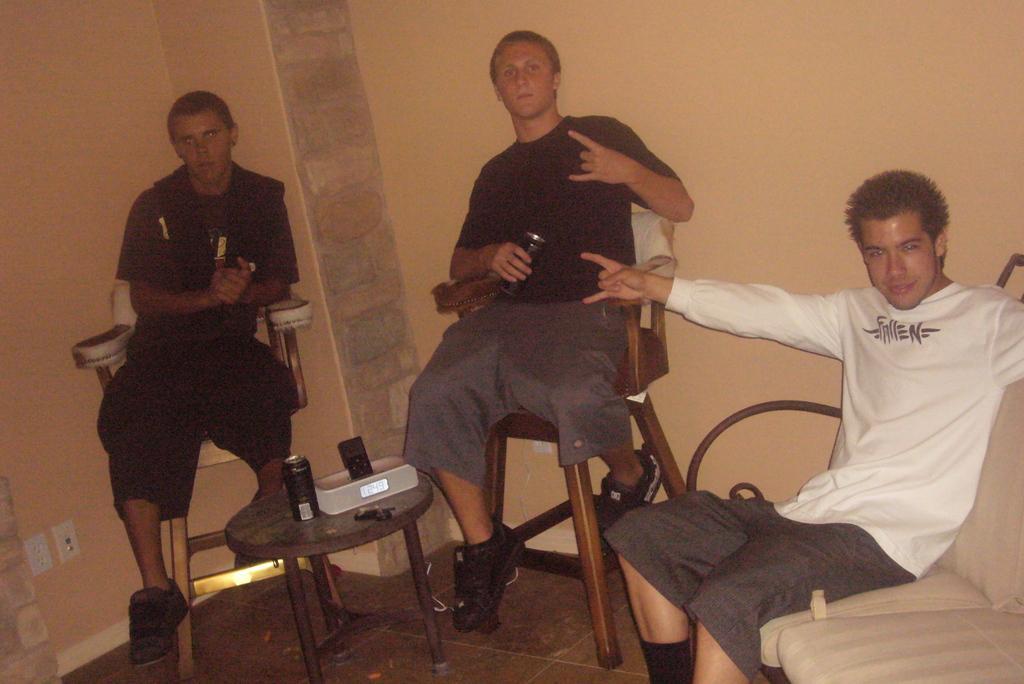Please provide a concise description of this image. In this image we can see three people in a room, a person is sitting on a couch, two people are sitting on a chair, a person is holding a tin and there is a table in the middle of the image, on the table there is a tin and a few objects and wall in the background. 